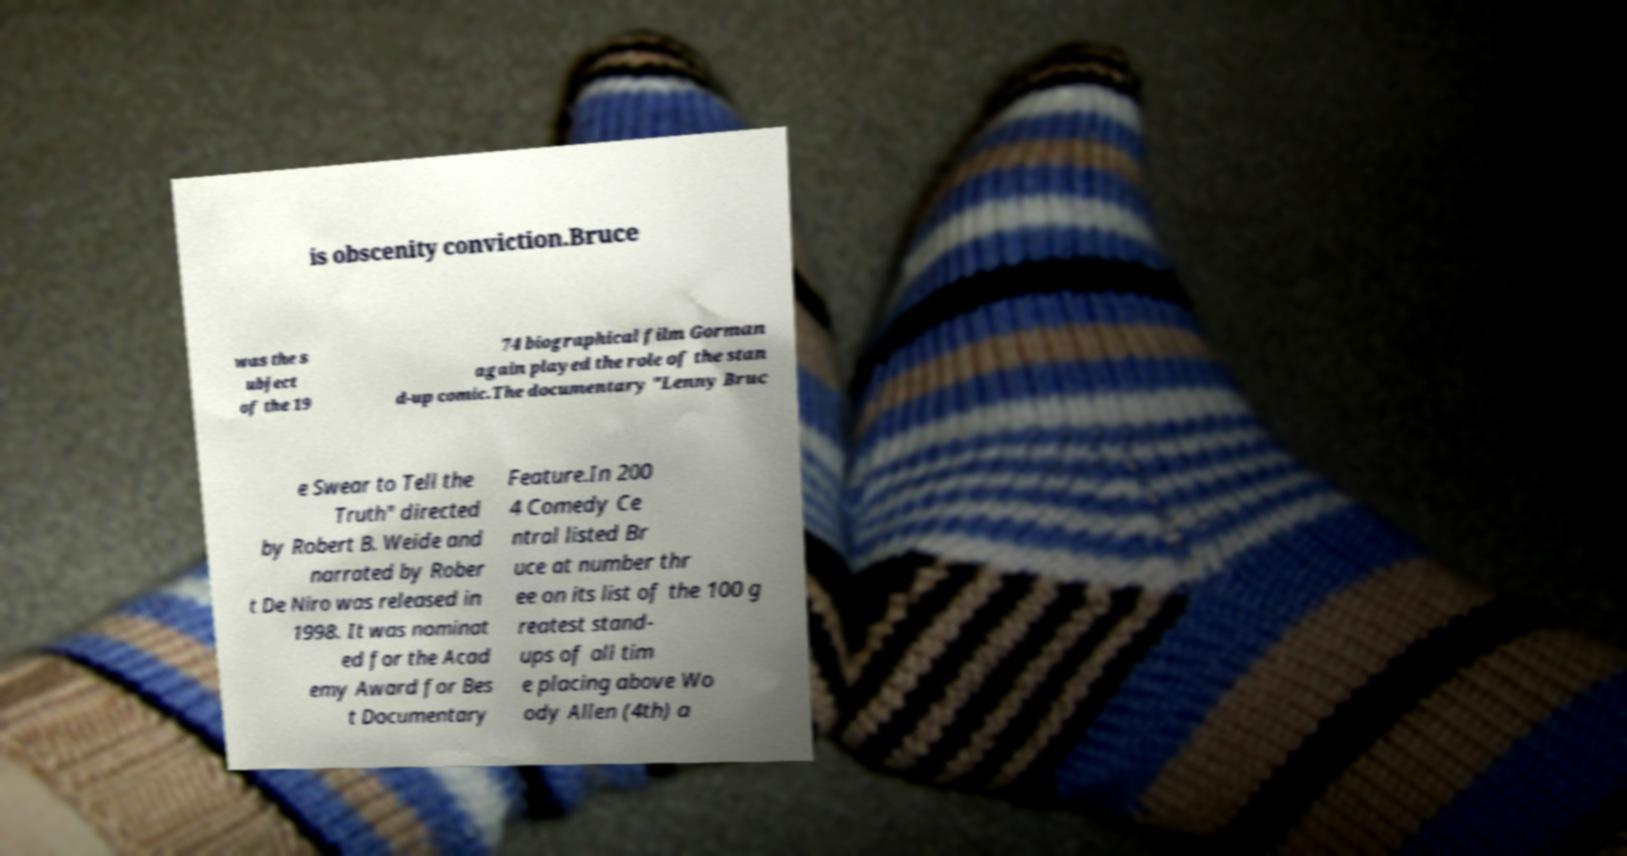Could you extract and type out the text from this image? is obscenity conviction.Bruce was the s ubject of the 19 74 biographical film Gorman again played the role of the stan d-up comic.The documentary "Lenny Bruc e Swear to Tell the Truth" directed by Robert B. Weide and narrated by Rober t De Niro was released in 1998. It was nominat ed for the Acad emy Award for Bes t Documentary Feature.In 200 4 Comedy Ce ntral listed Br uce at number thr ee on its list of the 100 g reatest stand- ups of all tim e placing above Wo ody Allen (4th) a 